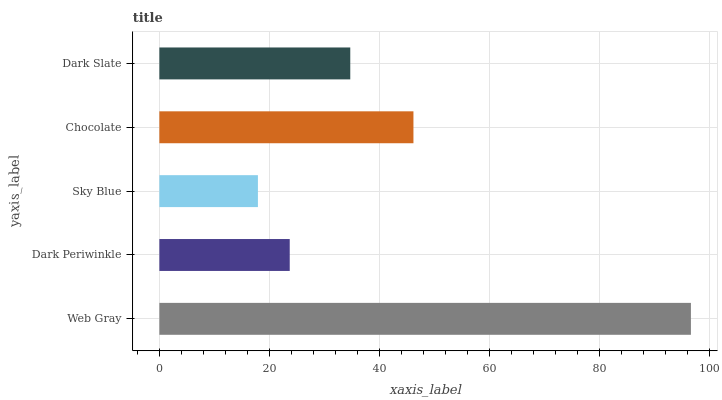Is Sky Blue the minimum?
Answer yes or no. Yes. Is Web Gray the maximum?
Answer yes or no. Yes. Is Dark Periwinkle the minimum?
Answer yes or no. No. Is Dark Periwinkle the maximum?
Answer yes or no. No. Is Web Gray greater than Dark Periwinkle?
Answer yes or no. Yes. Is Dark Periwinkle less than Web Gray?
Answer yes or no. Yes. Is Dark Periwinkle greater than Web Gray?
Answer yes or no. No. Is Web Gray less than Dark Periwinkle?
Answer yes or no. No. Is Dark Slate the high median?
Answer yes or no. Yes. Is Dark Slate the low median?
Answer yes or no. Yes. Is Sky Blue the high median?
Answer yes or no. No. Is Dark Periwinkle the low median?
Answer yes or no. No. 